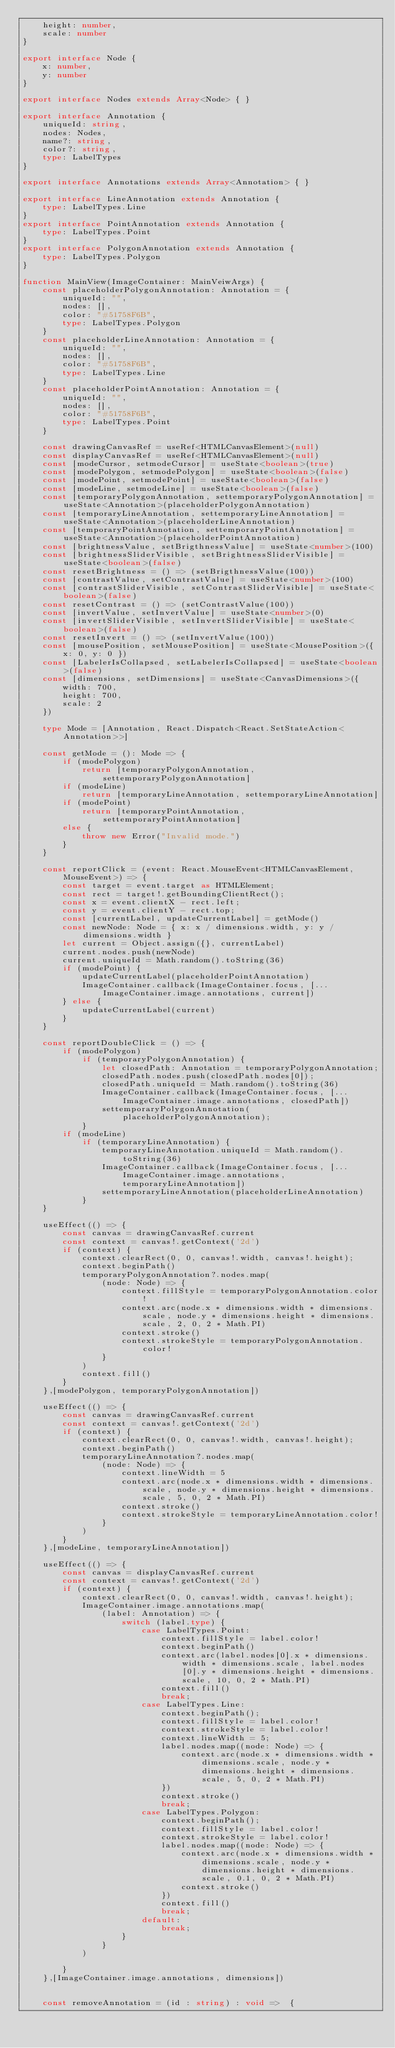<code> <loc_0><loc_0><loc_500><loc_500><_TypeScript_>    height: number,
    scale: number
}

export interface Node {
    x: number,
    y: number
}

export interface Nodes extends Array<Node> { }

export interface Annotation {
    uniqueId: string,
    nodes: Nodes,
    name?: string,
    color?: string,
    type: LabelTypes
}

export interface Annotations extends Array<Annotation> { }

export interface LineAnnotation extends Annotation {
    type: LabelTypes.Line
}
export interface PointAnnotation extends Annotation {
    type: LabelTypes.Point
}
export interface PolygonAnnotation extends Annotation {
    type: LabelTypes.Polygon
}

function MainView(ImageContainer: MainVeiwArgs) {
    const placeholderPolygonAnnotation: Annotation = {
        uniqueId: "",
        nodes: [],
        color: "#51758F6B",
        type: LabelTypes.Polygon
    }
    const placeholderLineAnnotation: Annotation = {
        uniqueId: "",
        nodes: [],
        color: "#51758F6B",
        type: LabelTypes.Line
    }
    const placeholderPointAnnotation: Annotation = {
        uniqueId: "",
        nodes: [],
        color: "#51758F6B",
        type: LabelTypes.Point
    }

    const drawingCanvasRef = useRef<HTMLCanvasElement>(null)
    const displayCanvasRef = useRef<HTMLCanvasElement>(null)
    const [modeCursor, setmodeCursor] = useState<boolean>(true)
    const [modePolygon, setmodePolygon] = useState<boolean>(false)
    const [modePoint, setmodePoint] = useState<boolean>(false)
    const [modeLine, setmodeLine] = useState<boolean>(false)
    const [temporaryPolygonAnnotation, settemporaryPolygonAnnotation] = useState<Annotation>(placeholderPolygonAnnotation)
    const [temporaryLineAnnotation, settemporaryLineAnnotation] = useState<Annotation>(placeholderLineAnnotation)
    const [temporaryPointAnnotation, settemporaryPointAnnotation] = useState<Annotation>(placeholderPointAnnotation)
    const [brightnessValue, setBrigthnessValue] = useState<number>(100)
    const [brightnessSliderVisible, setBrightnessSliderVisible] = useState<boolean>(false)
    const resetBrightness = () => (setBrigthnessValue(100))
    const [contrastValue, setContrastValue] = useState<number>(100)
    const [contrastSliderVisible, setContrastSliderVisible] = useState<boolean>(false)
    const resetContrast = () => (setContrastValue(100))
    const [invertValue, setInvertValue] = useState<number>(0)
    const [invertSliderVisible, setInvertSliderVisible] = useState<boolean>(false)
    const resetInvert = () => (setInvertValue(100))
    const [mousePosition, setMousePosition] = useState<MousePosition>({ x: 0, y: 0 })
    const [LabelerIsCollapsed, setLabelerIsCollapsed] = useState<boolean>(false)
    const [dimensions, setDimensions] = useState<CanvasDimensions>({
        width: 700,
        height: 700,
        scale: 2
    })

    type Mode = [Annotation, React.Dispatch<React.SetStateAction<Annotation>>]

    const getMode = (): Mode => {
        if (modePolygon)
            return [temporaryPolygonAnnotation, settemporaryPolygonAnnotation]
        if (modeLine)
            return [temporaryLineAnnotation, settemporaryLineAnnotation]
        if (modePoint)
            return [temporaryPointAnnotation, settemporaryPointAnnotation]
        else {
            throw new Error("Invalid mode.")
        }
    }

    const reportClick = (event: React.MouseEvent<HTMLCanvasElement, MouseEvent>) => {
        const target = event.target as HTMLElement;
        const rect = target!.getBoundingClientRect();
        const x = event.clientX - rect.left;
        const y = event.clientY - rect.top;
        const [currentLabel, updateCurrentLabel] = getMode()
        const newNode: Node = { x: x / dimensions.width, y: y / dimensions.width }
        let current = Object.assign({}, currentLabel)
        current.nodes.push(newNode)
        current.uniqueId = Math.random().toString(36)
        if (modePoint) {
            updateCurrentLabel(placeholderPointAnnotation)
            ImageContainer.callback(ImageContainer.focus, [...ImageContainer.image.annotations, current])
        } else {
            updateCurrentLabel(current)
        }
    }

    const reportDoubleClick = () => {
        if (modePolygon)
            if (temporaryPolygonAnnotation) {
                let closedPath: Annotation = temporaryPolygonAnnotation;
                closedPath.nodes.push(closedPath.nodes[0]);
                closedPath.uniqueId = Math.random().toString(36)
                ImageContainer.callback(ImageContainer.focus, [...ImageContainer.image.annotations, closedPath])
                settemporaryPolygonAnnotation(placeholderPolygonAnnotation);
            }
        if (modeLine)
            if (temporaryLineAnnotation) {
                temporaryLineAnnotation.uniqueId = Math.random().toString(36)
                ImageContainer.callback(ImageContainer.focus, [...ImageContainer.image.annotations, temporaryLineAnnotation])
                settemporaryLineAnnotation(placeholderLineAnnotation)
            }
    }

    useEffect(() => {
        const canvas = drawingCanvasRef.current
        const context = canvas!.getContext('2d')
        if (context) {
            context.clearRect(0, 0, canvas!.width, canvas!.height);
            context.beginPath()
            temporaryPolygonAnnotation?.nodes.map(
                (node: Node) => {
                    context.fillStyle = temporaryPolygonAnnotation.color!
                    context.arc(node.x * dimensions.width * dimensions.scale, node.y * dimensions.height * dimensions.scale, 2, 0, 2 * Math.PI)
                    context.stroke()
                    context.strokeStyle = temporaryPolygonAnnotation.color!
                }
            )
            context.fill()
        }
    },[modePolygon, temporaryPolygonAnnotation])

    useEffect(() => {
        const canvas = drawingCanvasRef.current
        const context = canvas!.getContext('2d')
        if (context) {
            context.clearRect(0, 0, canvas!.width, canvas!.height);
            context.beginPath()
            temporaryLineAnnotation?.nodes.map(
                (node: Node) => {
                    context.lineWidth = 5
                    context.arc(node.x * dimensions.width * dimensions.scale, node.y * dimensions.height * dimensions.scale, 5, 0, 2 * Math.PI)
                    context.stroke()
                    context.strokeStyle = temporaryLineAnnotation.color!
                }
            )
        }
    },[modeLine, temporaryLineAnnotation])

    useEffect(() => {
        const canvas = displayCanvasRef.current
        const context = canvas!.getContext('2d')
        if (context) {
            context.clearRect(0, 0, canvas!.width, canvas!.height);
            ImageContainer.image.annotations.map(
                (label: Annotation) => {
                    switch (label.type) {
                        case LabelTypes.Point:
                            context.fillStyle = label.color!
                            context.beginPath()
                            context.arc(label.nodes[0].x * dimensions.width * dimensions.scale, label.nodes[0].y * dimensions.height * dimensions.scale, 10, 0, 2 * Math.PI)
                            context.fill()
                            break;
                        case LabelTypes.Line:
                            context.beginPath();
                            context.fillStyle = label.color!
                            context.strokeStyle = label.color!
                            context.lineWidth = 5;
                            label.nodes.map((node: Node) => {
                                context.arc(node.x * dimensions.width * dimensions.scale, node.y * dimensions.height * dimensions.scale, 5, 0, 2 * Math.PI)
                            })
                            context.stroke()
                            break;
                        case LabelTypes.Polygon:
                            context.beginPath();
                            context.fillStyle = label.color!
                            context.strokeStyle = label.color!
                            label.nodes.map((node: Node) => {
                                context.arc(node.x * dimensions.width * dimensions.scale, node.y * dimensions.height * dimensions.scale, 0.1, 0, 2 * Math.PI)
                                context.stroke()
                            })
                            context.fill()
                            break;
                        default:
                            break;
                    }
                }
            )

        }
    },[ImageContainer.image.annotations, dimensions])

   
    const removeAnnotation = (id : string) : void =>  {</code> 